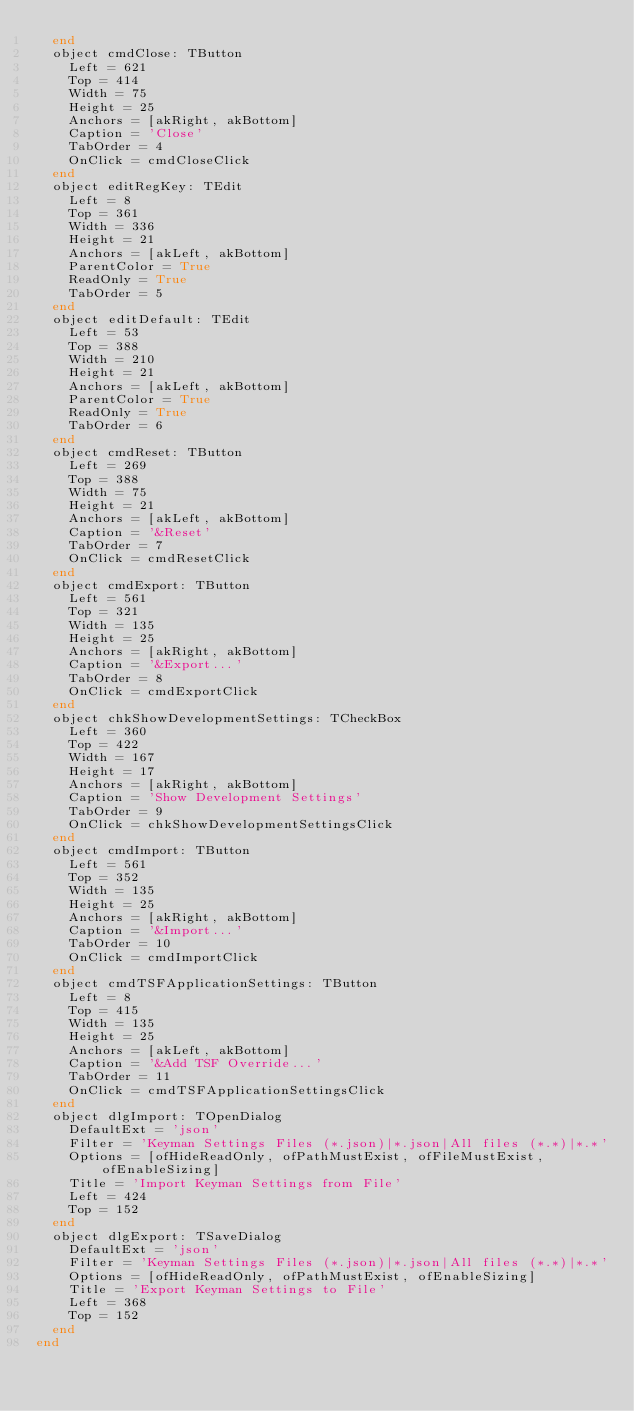Convert code to text. <code><loc_0><loc_0><loc_500><loc_500><_Pascal_>  end
  object cmdClose: TButton
    Left = 621
    Top = 414
    Width = 75
    Height = 25
    Anchors = [akRight, akBottom]
    Caption = 'Close'
    TabOrder = 4
    OnClick = cmdCloseClick
  end
  object editRegKey: TEdit
    Left = 8
    Top = 361
    Width = 336
    Height = 21
    Anchors = [akLeft, akBottom]
    ParentColor = True
    ReadOnly = True
    TabOrder = 5
  end
  object editDefault: TEdit
    Left = 53
    Top = 388
    Width = 210
    Height = 21
    Anchors = [akLeft, akBottom]
    ParentColor = True
    ReadOnly = True
    TabOrder = 6
  end
  object cmdReset: TButton
    Left = 269
    Top = 388
    Width = 75
    Height = 21
    Anchors = [akLeft, akBottom]
    Caption = '&Reset'
    TabOrder = 7
    OnClick = cmdResetClick
  end
  object cmdExport: TButton
    Left = 561
    Top = 321
    Width = 135
    Height = 25
    Anchors = [akRight, akBottom]
    Caption = '&Export...'
    TabOrder = 8
    OnClick = cmdExportClick
  end
  object chkShowDevelopmentSettings: TCheckBox
    Left = 360
    Top = 422
    Width = 167
    Height = 17
    Anchors = [akRight, akBottom]
    Caption = 'Show Development Settings'
    TabOrder = 9
    OnClick = chkShowDevelopmentSettingsClick
  end
  object cmdImport: TButton
    Left = 561
    Top = 352
    Width = 135
    Height = 25
    Anchors = [akRight, akBottom]
    Caption = '&Import...'
    TabOrder = 10
    OnClick = cmdImportClick
  end
  object cmdTSFApplicationSettings: TButton
    Left = 8
    Top = 415
    Width = 135
    Height = 25
    Anchors = [akLeft, akBottom]
    Caption = '&Add TSF Override...'
    TabOrder = 11
    OnClick = cmdTSFApplicationSettingsClick
  end
  object dlgImport: TOpenDialog
    DefaultExt = 'json'
    Filter = 'Keyman Settings Files (*.json)|*.json|All files (*.*)|*.*'
    Options = [ofHideReadOnly, ofPathMustExist, ofFileMustExist, ofEnableSizing]
    Title = 'Import Keyman Settings from File'
    Left = 424
    Top = 152
  end
  object dlgExport: TSaveDialog
    DefaultExt = 'json'
    Filter = 'Keyman Settings Files (*.json)|*.json|All files (*.*)|*.*'
    Options = [ofHideReadOnly, ofPathMustExist, ofEnableSizing]
    Title = 'Export Keyman Settings to File'
    Left = 368
    Top = 152
  end
end
</code> 